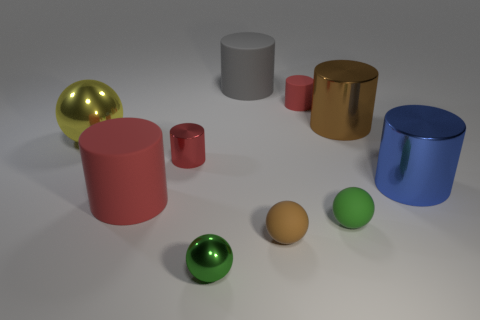What is the size of the metallic object that is both right of the big red rubber cylinder and behind the small metal cylinder?
Provide a short and direct response. Large. Is there a tiny matte cube of the same color as the tiny matte cylinder?
Give a very brief answer. No. What color is the big shiny cylinder that is right of the big shiny object that is behind the large yellow metal sphere?
Your answer should be compact. Blue. Is the number of big blue metal things on the left side of the large blue shiny object less than the number of small green metallic things that are in front of the gray cylinder?
Make the answer very short. Yes. Is the size of the yellow object the same as the blue shiny cylinder?
Ensure brevity in your answer.  Yes. What is the shape of the small thing that is both left of the gray cylinder and in front of the big red cylinder?
Provide a short and direct response. Sphere. What number of small green things have the same material as the small brown ball?
Keep it short and to the point. 1. There is a big rubber object in front of the gray matte cylinder; how many objects are behind it?
Keep it short and to the point. 6. There is a green thing on the right side of the green ball left of the rubber cylinder to the right of the big gray rubber thing; what is its shape?
Make the answer very short. Sphere. What size is the object that is the same color as the tiny shiny ball?
Make the answer very short. Small. 